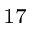Convert formula to latex. <formula><loc_0><loc_0><loc_500><loc_500>_ { 1 7 }</formula> 